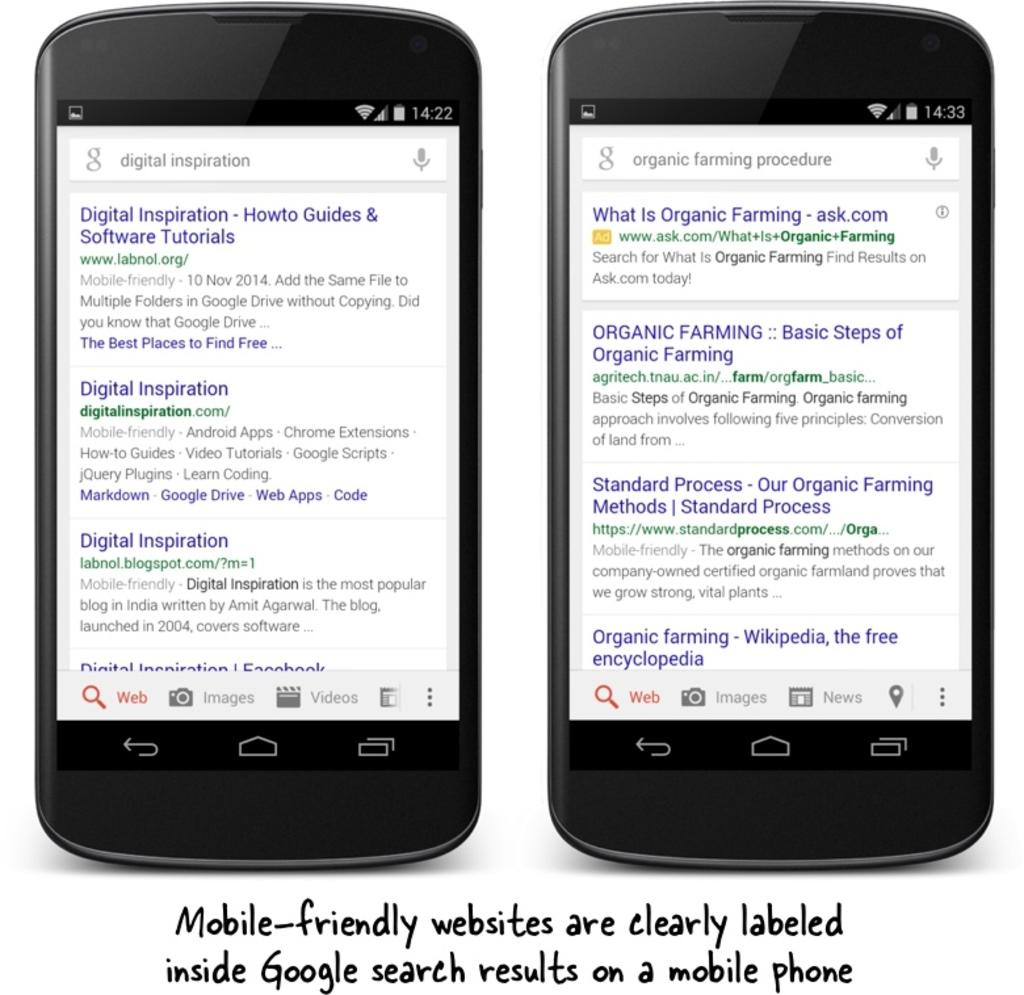<image>
Offer a succinct explanation of the picture presented. Two phones displaying various google searches on the entire screen 